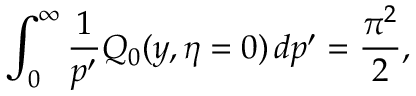Convert formula to latex. <formula><loc_0><loc_0><loc_500><loc_500>\int _ { 0 } ^ { \infty } { \frac { 1 } { p ^ { \prime } } } Q _ { 0 } ( y , \eta = 0 ) \, d p ^ { \prime } = { \frac { \pi ^ { 2 } } { 2 } } ,</formula> 